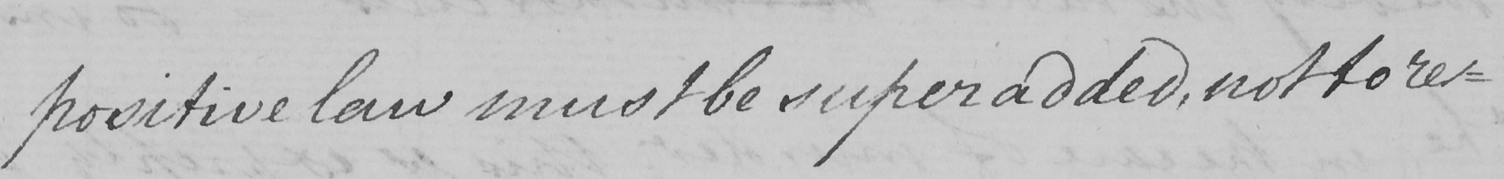Please transcribe the handwritten text in this image. positive law must be superadded , not to re- 